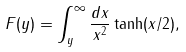Convert formula to latex. <formula><loc_0><loc_0><loc_500><loc_500>F ( y ) = \int _ { y } ^ { \infty } \frac { d x } { x ^ { 2 } } \tanh ( x / 2 ) ,</formula> 